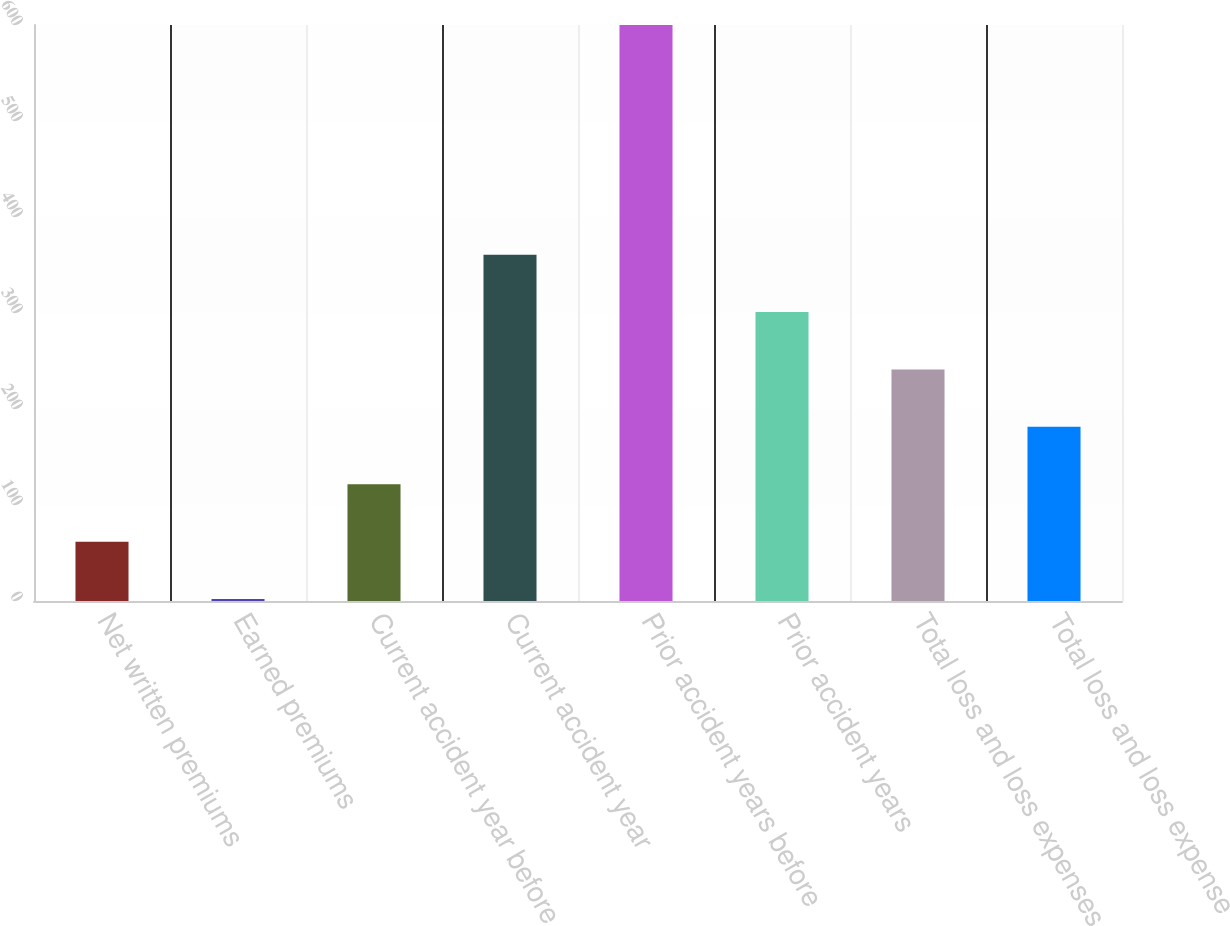Convert chart. <chart><loc_0><loc_0><loc_500><loc_500><bar_chart><fcel>Net written premiums<fcel>Earned premiums<fcel>Current accident year before<fcel>Current accident year<fcel>Prior accident years before<fcel>Prior accident years<fcel>Total loss and loss expenses<fcel>Total loss and loss expense<nl><fcel>61.8<fcel>2<fcel>121.6<fcel>360.8<fcel>600<fcel>301<fcel>241.2<fcel>181.4<nl></chart> 